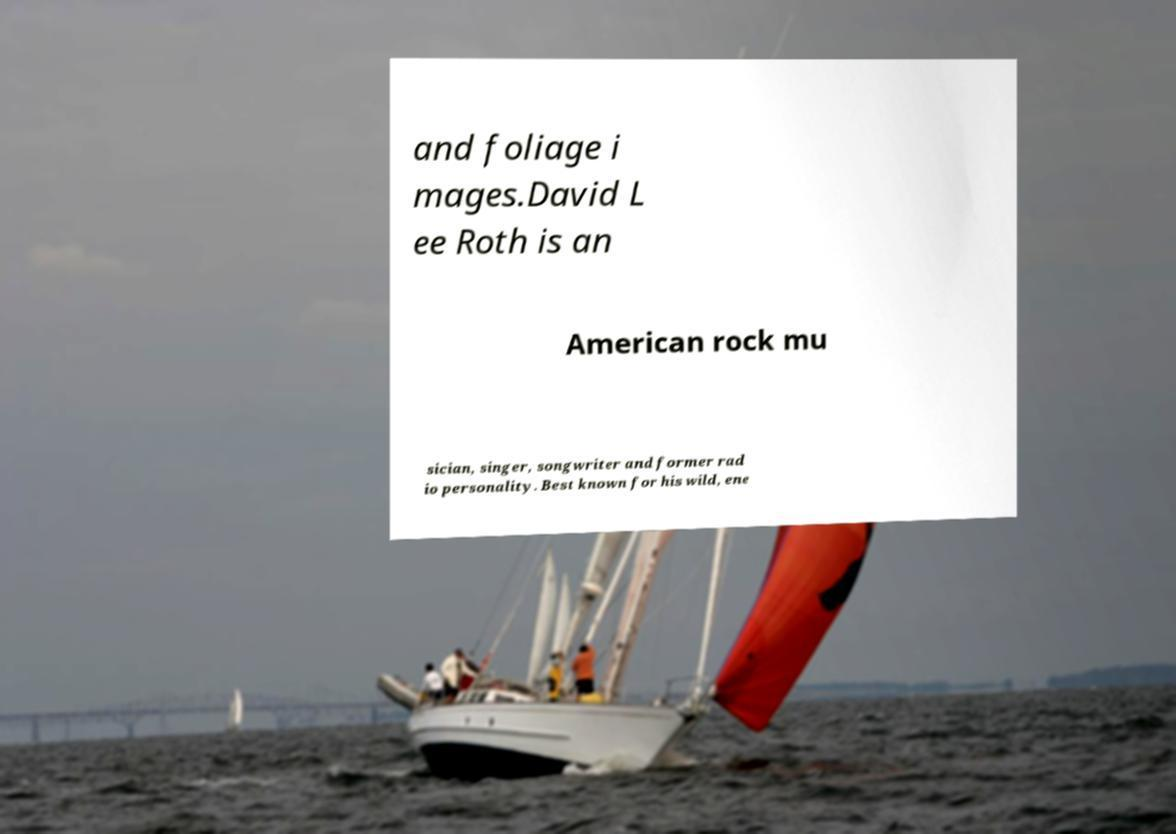Please identify and transcribe the text found in this image. and foliage i mages.David L ee Roth is an American rock mu sician, singer, songwriter and former rad io personality. Best known for his wild, ene 